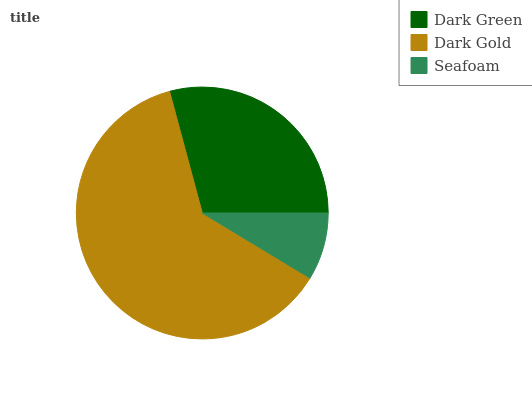Is Seafoam the minimum?
Answer yes or no. Yes. Is Dark Gold the maximum?
Answer yes or no. Yes. Is Dark Gold the minimum?
Answer yes or no. No. Is Seafoam the maximum?
Answer yes or no. No. Is Dark Gold greater than Seafoam?
Answer yes or no. Yes. Is Seafoam less than Dark Gold?
Answer yes or no. Yes. Is Seafoam greater than Dark Gold?
Answer yes or no. No. Is Dark Gold less than Seafoam?
Answer yes or no. No. Is Dark Green the high median?
Answer yes or no. Yes. Is Dark Green the low median?
Answer yes or no. Yes. Is Seafoam the high median?
Answer yes or no. No. Is Seafoam the low median?
Answer yes or no. No. 